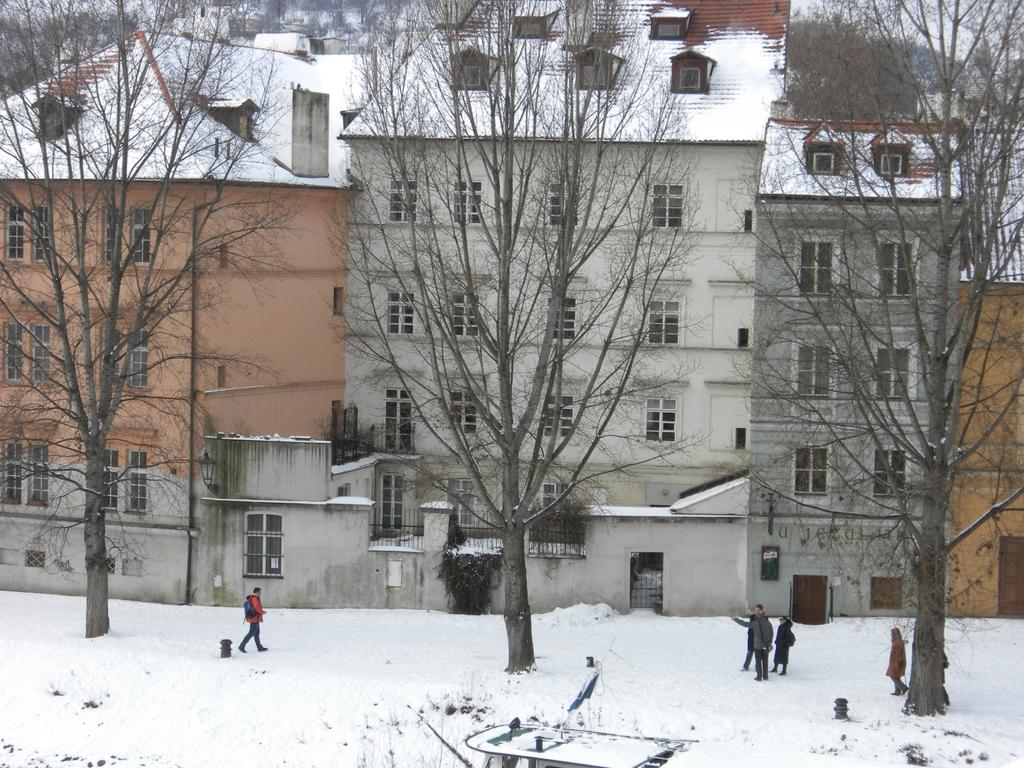What are the people in the image doing? There are people standing in the image. Can you describe the activity of one of the people? A person is walking on the snow in the image. What can be seen in the background of the image? There are trees and buildings visible in the background of the image. What color is the grape that the person is holding in the image? There is no grape present in the image. How does the person's hair look like in the image? The image does not provide enough detail to describe the person's hair. 